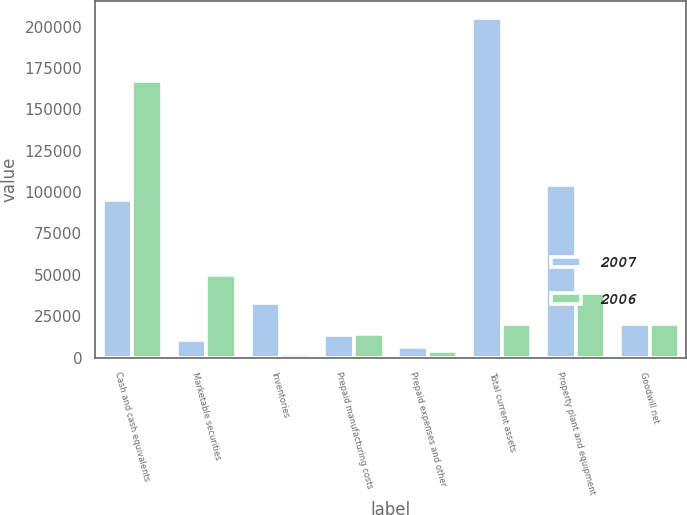<chart> <loc_0><loc_0><loc_500><loc_500><stacked_bar_chart><ecel><fcel>Cash and cash equivalents<fcel>Marketable securities<fcel>Inventories<fcel>Prepaid manufacturing costs<fcel>Prepaid expenses and other<fcel>Total current assets<fcel>Property plant and equipment<fcel>Goodwill net<nl><fcel>2007<fcel>95321<fcel>10433<fcel>32907<fcel>13775<fcel>6640<fcel>205354<fcel>104280<fcel>19954<nl><fcel>2006<fcel>166826<fcel>49728<fcel>2314<fcel>13935<fcel>3973<fcel>19954<fcel>39135<fcel>19954<nl></chart> 